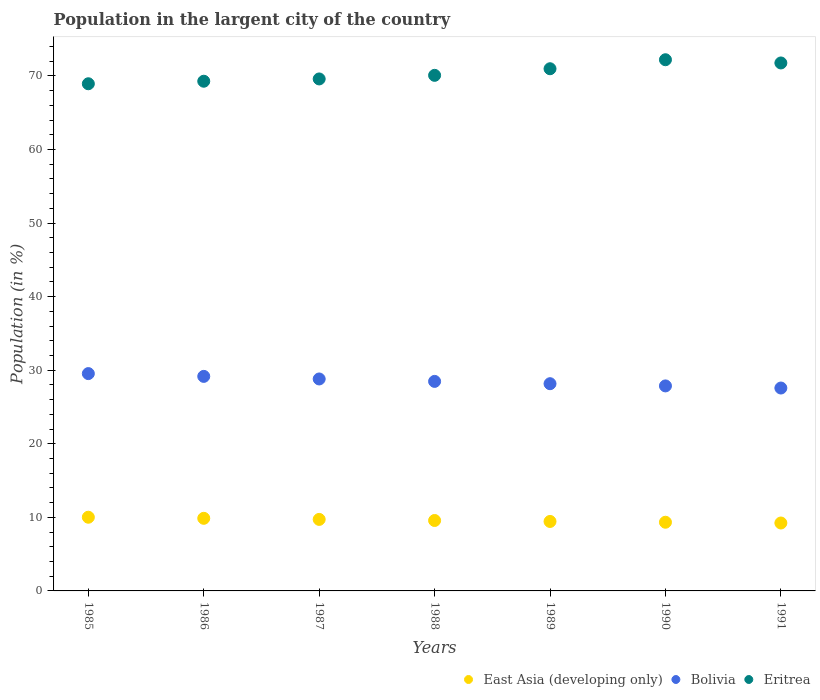How many different coloured dotlines are there?
Provide a short and direct response. 3. What is the percentage of population in the largent city in East Asia (developing only) in 1985?
Offer a terse response. 10.02. Across all years, what is the maximum percentage of population in the largent city in Bolivia?
Your answer should be very brief. 29.54. Across all years, what is the minimum percentage of population in the largent city in Eritrea?
Ensure brevity in your answer.  68.94. In which year was the percentage of population in the largent city in Eritrea maximum?
Offer a very short reply. 1990. In which year was the percentage of population in the largent city in Eritrea minimum?
Provide a short and direct response. 1985. What is the total percentage of population in the largent city in Eritrea in the graph?
Provide a succinct answer. 492.83. What is the difference between the percentage of population in the largent city in Bolivia in 1988 and that in 1991?
Provide a short and direct response. 0.9. What is the difference between the percentage of population in the largent city in Eritrea in 1990 and the percentage of population in the largent city in East Asia (developing only) in 1987?
Make the answer very short. 62.48. What is the average percentage of population in the largent city in Eritrea per year?
Offer a very short reply. 70.4. In the year 1986, what is the difference between the percentage of population in the largent city in East Asia (developing only) and percentage of population in the largent city in Bolivia?
Give a very brief answer. -19.29. In how many years, is the percentage of population in the largent city in East Asia (developing only) greater than 56 %?
Your response must be concise. 0. What is the ratio of the percentage of population in the largent city in East Asia (developing only) in 1989 to that in 1990?
Ensure brevity in your answer.  1.01. Is the percentage of population in the largent city in Eritrea in 1986 less than that in 1989?
Keep it short and to the point. Yes. What is the difference between the highest and the second highest percentage of population in the largent city in Eritrea?
Provide a succinct answer. 0.44. What is the difference between the highest and the lowest percentage of population in the largent city in Bolivia?
Your answer should be compact. 1.96. Is the sum of the percentage of population in the largent city in East Asia (developing only) in 1987 and 1990 greater than the maximum percentage of population in the largent city in Eritrea across all years?
Make the answer very short. No. Is it the case that in every year, the sum of the percentage of population in the largent city in Bolivia and percentage of population in the largent city in Eritrea  is greater than the percentage of population in the largent city in East Asia (developing only)?
Your answer should be very brief. Yes. Does the percentage of population in the largent city in East Asia (developing only) monotonically increase over the years?
Your response must be concise. No. Is the percentage of population in the largent city in Eritrea strictly greater than the percentage of population in the largent city in East Asia (developing only) over the years?
Your answer should be compact. Yes. How many dotlines are there?
Provide a short and direct response. 3. How many years are there in the graph?
Provide a succinct answer. 7. Are the values on the major ticks of Y-axis written in scientific E-notation?
Provide a short and direct response. No. Does the graph contain any zero values?
Your answer should be very brief. No. How are the legend labels stacked?
Keep it short and to the point. Horizontal. What is the title of the graph?
Give a very brief answer. Population in the largent city of the country. Does "Puerto Rico" appear as one of the legend labels in the graph?
Offer a very short reply. No. What is the label or title of the Y-axis?
Your response must be concise. Population (in %). What is the Population (in %) in East Asia (developing only) in 1985?
Provide a short and direct response. 10.02. What is the Population (in %) in Bolivia in 1985?
Your response must be concise. 29.54. What is the Population (in %) of Eritrea in 1985?
Your answer should be very brief. 68.94. What is the Population (in %) in East Asia (developing only) in 1986?
Your answer should be very brief. 9.87. What is the Population (in %) of Bolivia in 1986?
Keep it short and to the point. 29.16. What is the Population (in %) in Eritrea in 1986?
Your response must be concise. 69.28. What is the Population (in %) in East Asia (developing only) in 1987?
Provide a short and direct response. 9.72. What is the Population (in %) of Bolivia in 1987?
Your answer should be very brief. 28.81. What is the Population (in %) in Eritrea in 1987?
Keep it short and to the point. 69.59. What is the Population (in %) of East Asia (developing only) in 1988?
Keep it short and to the point. 9.57. What is the Population (in %) of Bolivia in 1988?
Provide a succinct answer. 28.48. What is the Population (in %) of Eritrea in 1988?
Provide a short and direct response. 70.08. What is the Population (in %) of East Asia (developing only) in 1989?
Ensure brevity in your answer.  9.44. What is the Population (in %) in Bolivia in 1989?
Offer a very short reply. 28.17. What is the Population (in %) in Eritrea in 1989?
Ensure brevity in your answer.  70.98. What is the Population (in %) of East Asia (developing only) in 1990?
Provide a succinct answer. 9.34. What is the Population (in %) of Bolivia in 1990?
Ensure brevity in your answer.  27.87. What is the Population (in %) in Eritrea in 1990?
Keep it short and to the point. 72.2. What is the Population (in %) of East Asia (developing only) in 1991?
Provide a succinct answer. 9.23. What is the Population (in %) in Bolivia in 1991?
Your answer should be compact. 27.58. What is the Population (in %) of Eritrea in 1991?
Offer a terse response. 71.76. Across all years, what is the maximum Population (in %) in East Asia (developing only)?
Provide a short and direct response. 10.02. Across all years, what is the maximum Population (in %) in Bolivia?
Make the answer very short. 29.54. Across all years, what is the maximum Population (in %) of Eritrea?
Give a very brief answer. 72.2. Across all years, what is the minimum Population (in %) of East Asia (developing only)?
Offer a terse response. 9.23. Across all years, what is the minimum Population (in %) in Bolivia?
Provide a succinct answer. 27.58. Across all years, what is the minimum Population (in %) of Eritrea?
Offer a terse response. 68.94. What is the total Population (in %) in East Asia (developing only) in the graph?
Keep it short and to the point. 67.19. What is the total Population (in %) in Bolivia in the graph?
Your answer should be very brief. 199.6. What is the total Population (in %) of Eritrea in the graph?
Ensure brevity in your answer.  492.83. What is the difference between the Population (in %) of East Asia (developing only) in 1985 and that in 1986?
Your answer should be compact. 0.15. What is the difference between the Population (in %) in Bolivia in 1985 and that in 1986?
Give a very brief answer. 0.38. What is the difference between the Population (in %) of Eritrea in 1985 and that in 1986?
Give a very brief answer. -0.34. What is the difference between the Population (in %) in East Asia (developing only) in 1985 and that in 1987?
Provide a short and direct response. 0.3. What is the difference between the Population (in %) of Bolivia in 1985 and that in 1987?
Keep it short and to the point. 0.73. What is the difference between the Population (in %) of Eritrea in 1985 and that in 1987?
Give a very brief answer. -0.66. What is the difference between the Population (in %) of East Asia (developing only) in 1985 and that in 1988?
Give a very brief answer. 0.44. What is the difference between the Population (in %) of Bolivia in 1985 and that in 1988?
Provide a succinct answer. 1.06. What is the difference between the Population (in %) of Eritrea in 1985 and that in 1988?
Provide a short and direct response. -1.14. What is the difference between the Population (in %) in East Asia (developing only) in 1985 and that in 1989?
Keep it short and to the point. 0.58. What is the difference between the Population (in %) of Bolivia in 1985 and that in 1989?
Provide a succinct answer. 1.37. What is the difference between the Population (in %) of Eritrea in 1985 and that in 1989?
Keep it short and to the point. -2.04. What is the difference between the Population (in %) in East Asia (developing only) in 1985 and that in 1990?
Keep it short and to the point. 0.68. What is the difference between the Population (in %) of Bolivia in 1985 and that in 1990?
Provide a succinct answer. 1.67. What is the difference between the Population (in %) in Eritrea in 1985 and that in 1990?
Your response must be concise. -3.27. What is the difference between the Population (in %) in East Asia (developing only) in 1985 and that in 1991?
Make the answer very short. 0.79. What is the difference between the Population (in %) in Bolivia in 1985 and that in 1991?
Provide a short and direct response. 1.96. What is the difference between the Population (in %) in Eritrea in 1985 and that in 1991?
Give a very brief answer. -2.83. What is the difference between the Population (in %) in East Asia (developing only) in 1986 and that in 1987?
Provide a short and direct response. 0.15. What is the difference between the Population (in %) of Bolivia in 1986 and that in 1987?
Provide a succinct answer. 0.35. What is the difference between the Population (in %) of Eritrea in 1986 and that in 1987?
Your answer should be compact. -0.31. What is the difference between the Population (in %) of East Asia (developing only) in 1986 and that in 1988?
Provide a short and direct response. 0.3. What is the difference between the Population (in %) in Bolivia in 1986 and that in 1988?
Offer a very short reply. 0.68. What is the difference between the Population (in %) in Eritrea in 1986 and that in 1988?
Give a very brief answer. -0.8. What is the difference between the Population (in %) of East Asia (developing only) in 1986 and that in 1989?
Your response must be concise. 0.43. What is the difference between the Population (in %) in Eritrea in 1986 and that in 1989?
Keep it short and to the point. -1.7. What is the difference between the Population (in %) in East Asia (developing only) in 1986 and that in 1990?
Provide a succinct answer. 0.53. What is the difference between the Population (in %) in Bolivia in 1986 and that in 1990?
Your response must be concise. 1.3. What is the difference between the Population (in %) in Eritrea in 1986 and that in 1990?
Your response must be concise. -2.92. What is the difference between the Population (in %) of East Asia (developing only) in 1986 and that in 1991?
Your response must be concise. 0.64. What is the difference between the Population (in %) of Bolivia in 1986 and that in 1991?
Provide a succinct answer. 1.58. What is the difference between the Population (in %) of Eritrea in 1986 and that in 1991?
Provide a succinct answer. -2.48. What is the difference between the Population (in %) in East Asia (developing only) in 1987 and that in 1988?
Provide a short and direct response. 0.15. What is the difference between the Population (in %) of Bolivia in 1987 and that in 1988?
Make the answer very short. 0.33. What is the difference between the Population (in %) in Eritrea in 1987 and that in 1988?
Give a very brief answer. -0.49. What is the difference between the Population (in %) in East Asia (developing only) in 1987 and that in 1989?
Make the answer very short. 0.28. What is the difference between the Population (in %) of Bolivia in 1987 and that in 1989?
Provide a succinct answer. 0.64. What is the difference between the Population (in %) in Eritrea in 1987 and that in 1989?
Your answer should be very brief. -1.39. What is the difference between the Population (in %) in East Asia (developing only) in 1987 and that in 1990?
Provide a short and direct response. 0.39. What is the difference between the Population (in %) of Bolivia in 1987 and that in 1990?
Ensure brevity in your answer.  0.94. What is the difference between the Population (in %) in Eritrea in 1987 and that in 1990?
Provide a short and direct response. -2.61. What is the difference between the Population (in %) of East Asia (developing only) in 1987 and that in 1991?
Keep it short and to the point. 0.49. What is the difference between the Population (in %) of Bolivia in 1987 and that in 1991?
Your answer should be compact. 1.23. What is the difference between the Population (in %) in Eritrea in 1987 and that in 1991?
Your answer should be compact. -2.17. What is the difference between the Population (in %) in East Asia (developing only) in 1988 and that in 1989?
Your answer should be very brief. 0.13. What is the difference between the Population (in %) of Bolivia in 1988 and that in 1989?
Provide a short and direct response. 0.31. What is the difference between the Population (in %) of Eritrea in 1988 and that in 1989?
Ensure brevity in your answer.  -0.9. What is the difference between the Population (in %) in East Asia (developing only) in 1988 and that in 1990?
Your response must be concise. 0.24. What is the difference between the Population (in %) of Bolivia in 1988 and that in 1990?
Your answer should be compact. 0.61. What is the difference between the Population (in %) of Eritrea in 1988 and that in 1990?
Your response must be concise. -2.12. What is the difference between the Population (in %) of East Asia (developing only) in 1988 and that in 1991?
Ensure brevity in your answer.  0.34. What is the difference between the Population (in %) in Bolivia in 1988 and that in 1991?
Your response must be concise. 0.9. What is the difference between the Population (in %) of Eritrea in 1988 and that in 1991?
Offer a terse response. -1.68. What is the difference between the Population (in %) of East Asia (developing only) in 1989 and that in 1990?
Provide a succinct answer. 0.11. What is the difference between the Population (in %) of Bolivia in 1989 and that in 1990?
Your answer should be compact. 0.3. What is the difference between the Population (in %) of Eritrea in 1989 and that in 1990?
Offer a terse response. -1.22. What is the difference between the Population (in %) in East Asia (developing only) in 1989 and that in 1991?
Offer a very short reply. 0.21. What is the difference between the Population (in %) of Bolivia in 1989 and that in 1991?
Ensure brevity in your answer.  0.59. What is the difference between the Population (in %) in Eritrea in 1989 and that in 1991?
Your answer should be compact. -0.79. What is the difference between the Population (in %) in East Asia (developing only) in 1990 and that in 1991?
Your response must be concise. 0.1. What is the difference between the Population (in %) in Bolivia in 1990 and that in 1991?
Your answer should be compact. 0.29. What is the difference between the Population (in %) in Eritrea in 1990 and that in 1991?
Offer a very short reply. 0.44. What is the difference between the Population (in %) in East Asia (developing only) in 1985 and the Population (in %) in Bolivia in 1986?
Offer a very short reply. -19.15. What is the difference between the Population (in %) in East Asia (developing only) in 1985 and the Population (in %) in Eritrea in 1986?
Provide a short and direct response. -59.26. What is the difference between the Population (in %) in Bolivia in 1985 and the Population (in %) in Eritrea in 1986?
Your answer should be very brief. -39.74. What is the difference between the Population (in %) of East Asia (developing only) in 1985 and the Population (in %) of Bolivia in 1987?
Make the answer very short. -18.79. What is the difference between the Population (in %) in East Asia (developing only) in 1985 and the Population (in %) in Eritrea in 1987?
Your answer should be very brief. -59.58. What is the difference between the Population (in %) of Bolivia in 1985 and the Population (in %) of Eritrea in 1987?
Provide a succinct answer. -40.05. What is the difference between the Population (in %) in East Asia (developing only) in 1985 and the Population (in %) in Bolivia in 1988?
Ensure brevity in your answer.  -18.46. What is the difference between the Population (in %) in East Asia (developing only) in 1985 and the Population (in %) in Eritrea in 1988?
Offer a very short reply. -60.06. What is the difference between the Population (in %) in Bolivia in 1985 and the Population (in %) in Eritrea in 1988?
Your answer should be compact. -40.54. What is the difference between the Population (in %) of East Asia (developing only) in 1985 and the Population (in %) of Bolivia in 1989?
Provide a short and direct response. -18.15. What is the difference between the Population (in %) in East Asia (developing only) in 1985 and the Population (in %) in Eritrea in 1989?
Ensure brevity in your answer.  -60.96. What is the difference between the Population (in %) in Bolivia in 1985 and the Population (in %) in Eritrea in 1989?
Make the answer very short. -41.44. What is the difference between the Population (in %) in East Asia (developing only) in 1985 and the Population (in %) in Bolivia in 1990?
Give a very brief answer. -17.85. What is the difference between the Population (in %) in East Asia (developing only) in 1985 and the Population (in %) in Eritrea in 1990?
Offer a terse response. -62.18. What is the difference between the Population (in %) in Bolivia in 1985 and the Population (in %) in Eritrea in 1990?
Make the answer very short. -42.66. What is the difference between the Population (in %) in East Asia (developing only) in 1985 and the Population (in %) in Bolivia in 1991?
Your answer should be compact. -17.56. What is the difference between the Population (in %) of East Asia (developing only) in 1985 and the Population (in %) of Eritrea in 1991?
Provide a succinct answer. -61.75. What is the difference between the Population (in %) in Bolivia in 1985 and the Population (in %) in Eritrea in 1991?
Your answer should be compact. -42.22. What is the difference between the Population (in %) in East Asia (developing only) in 1986 and the Population (in %) in Bolivia in 1987?
Offer a terse response. -18.94. What is the difference between the Population (in %) in East Asia (developing only) in 1986 and the Population (in %) in Eritrea in 1987?
Provide a short and direct response. -59.72. What is the difference between the Population (in %) in Bolivia in 1986 and the Population (in %) in Eritrea in 1987?
Ensure brevity in your answer.  -40.43. What is the difference between the Population (in %) in East Asia (developing only) in 1986 and the Population (in %) in Bolivia in 1988?
Your response must be concise. -18.61. What is the difference between the Population (in %) in East Asia (developing only) in 1986 and the Population (in %) in Eritrea in 1988?
Your response must be concise. -60.21. What is the difference between the Population (in %) in Bolivia in 1986 and the Population (in %) in Eritrea in 1988?
Ensure brevity in your answer.  -40.92. What is the difference between the Population (in %) in East Asia (developing only) in 1986 and the Population (in %) in Bolivia in 1989?
Provide a succinct answer. -18.3. What is the difference between the Population (in %) in East Asia (developing only) in 1986 and the Population (in %) in Eritrea in 1989?
Your answer should be compact. -61.11. What is the difference between the Population (in %) in Bolivia in 1986 and the Population (in %) in Eritrea in 1989?
Your answer should be compact. -41.82. What is the difference between the Population (in %) in East Asia (developing only) in 1986 and the Population (in %) in Bolivia in 1990?
Provide a succinct answer. -18. What is the difference between the Population (in %) of East Asia (developing only) in 1986 and the Population (in %) of Eritrea in 1990?
Make the answer very short. -62.33. What is the difference between the Population (in %) in Bolivia in 1986 and the Population (in %) in Eritrea in 1990?
Offer a terse response. -43.04. What is the difference between the Population (in %) of East Asia (developing only) in 1986 and the Population (in %) of Bolivia in 1991?
Offer a terse response. -17.71. What is the difference between the Population (in %) of East Asia (developing only) in 1986 and the Population (in %) of Eritrea in 1991?
Your answer should be very brief. -61.89. What is the difference between the Population (in %) in Bolivia in 1986 and the Population (in %) in Eritrea in 1991?
Give a very brief answer. -42.6. What is the difference between the Population (in %) in East Asia (developing only) in 1987 and the Population (in %) in Bolivia in 1988?
Ensure brevity in your answer.  -18.76. What is the difference between the Population (in %) of East Asia (developing only) in 1987 and the Population (in %) of Eritrea in 1988?
Ensure brevity in your answer.  -60.36. What is the difference between the Population (in %) in Bolivia in 1987 and the Population (in %) in Eritrea in 1988?
Keep it short and to the point. -41.27. What is the difference between the Population (in %) of East Asia (developing only) in 1987 and the Population (in %) of Bolivia in 1989?
Offer a terse response. -18.45. What is the difference between the Population (in %) in East Asia (developing only) in 1987 and the Population (in %) in Eritrea in 1989?
Keep it short and to the point. -61.26. What is the difference between the Population (in %) in Bolivia in 1987 and the Population (in %) in Eritrea in 1989?
Provide a succinct answer. -42.17. What is the difference between the Population (in %) of East Asia (developing only) in 1987 and the Population (in %) of Bolivia in 1990?
Your answer should be compact. -18.15. What is the difference between the Population (in %) of East Asia (developing only) in 1987 and the Population (in %) of Eritrea in 1990?
Your response must be concise. -62.48. What is the difference between the Population (in %) of Bolivia in 1987 and the Population (in %) of Eritrea in 1990?
Your answer should be compact. -43.39. What is the difference between the Population (in %) of East Asia (developing only) in 1987 and the Population (in %) of Bolivia in 1991?
Offer a terse response. -17.86. What is the difference between the Population (in %) in East Asia (developing only) in 1987 and the Population (in %) in Eritrea in 1991?
Your answer should be compact. -62.04. What is the difference between the Population (in %) of Bolivia in 1987 and the Population (in %) of Eritrea in 1991?
Your response must be concise. -42.95. What is the difference between the Population (in %) of East Asia (developing only) in 1988 and the Population (in %) of Bolivia in 1989?
Your answer should be compact. -18.59. What is the difference between the Population (in %) of East Asia (developing only) in 1988 and the Population (in %) of Eritrea in 1989?
Your answer should be compact. -61.4. What is the difference between the Population (in %) in Bolivia in 1988 and the Population (in %) in Eritrea in 1989?
Provide a succinct answer. -42.5. What is the difference between the Population (in %) of East Asia (developing only) in 1988 and the Population (in %) of Bolivia in 1990?
Ensure brevity in your answer.  -18.29. What is the difference between the Population (in %) of East Asia (developing only) in 1988 and the Population (in %) of Eritrea in 1990?
Keep it short and to the point. -62.63. What is the difference between the Population (in %) in Bolivia in 1988 and the Population (in %) in Eritrea in 1990?
Provide a short and direct response. -43.72. What is the difference between the Population (in %) in East Asia (developing only) in 1988 and the Population (in %) in Bolivia in 1991?
Keep it short and to the point. -18.01. What is the difference between the Population (in %) of East Asia (developing only) in 1988 and the Population (in %) of Eritrea in 1991?
Offer a very short reply. -62.19. What is the difference between the Population (in %) in Bolivia in 1988 and the Population (in %) in Eritrea in 1991?
Offer a very short reply. -43.28. What is the difference between the Population (in %) in East Asia (developing only) in 1989 and the Population (in %) in Bolivia in 1990?
Offer a terse response. -18.43. What is the difference between the Population (in %) of East Asia (developing only) in 1989 and the Population (in %) of Eritrea in 1990?
Provide a succinct answer. -62.76. What is the difference between the Population (in %) of Bolivia in 1989 and the Population (in %) of Eritrea in 1990?
Your answer should be very brief. -44.03. What is the difference between the Population (in %) in East Asia (developing only) in 1989 and the Population (in %) in Bolivia in 1991?
Make the answer very short. -18.14. What is the difference between the Population (in %) of East Asia (developing only) in 1989 and the Population (in %) of Eritrea in 1991?
Offer a terse response. -62.32. What is the difference between the Population (in %) in Bolivia in 1989 and the Population (in %) in Eritrea in 1991?
Provide a succinct answer. -43.6. What is the difference between the Population (in %) in East Asia (developing only) in 1990 and the Population (in %) in Bolivia in 1991?
Your answer should be compact. -18.24. What is the difference between the Population (in %) of East Asia (developing only) in 1990 and the Population (in %) of Eritrea in 1991?
Your answer should be very brief. -62.43. What is the difference between the Population (in %) of Bolivia in 1990 and the Population (in %) of Eritrea in 1991?
Keep it short and to the point. -43.9. What is the average Population (in %) in East Asia (developing only) per year?
Ensure brevity in your answer.  9.6. What is the average Population (in %) of Bolivia per year?
Give a very brief answer. 28.51. What is the average Population (in %) in Eritrea per year?
Your answer should be compact. 70.4. In the year 1985, what is the difference between the Population (in %) in East Asia (developing only) and Population (in %) in Bolivia?
Make the answer very short. -19.52. In the year 1985, what is the difference between the Population (in %) in East Asia (developing only) and Population (in %) in Eritrea?
Provide a succinct answer. -58.92. In the year 1985, what is the difference between the Population (in %) of Bolivia and Population (in %) of Eritrea?
Offer a terse response. -39.4. In the year 1986, what is the difference between the Population (in %) in East Asia (developing only) and Population (in %) in Bolivia?
Your answer should be very brief. -19.29. In the year 1986, what is the difference between the Population (in %) in East Asia (developing only) and Population (in %) in Eritrea?
Offer a terse response. -59.41. In the year 1986, what is the difference between the Population (in %) of Bolivia and Population (in %) of Eritrea?
Give a very brief answer. -40.12. In the year 1987, what is the difference between the Population (in %) of East Asia (developing only) and Population (in %) of Bolivia?
Give a very brief answer. -19.09. In the year 1987, what is the difference between the Population (in %) of East Asia (developing only) and Population (in %) of Eritrea?
Make the answer very short. -59.87. In the year 1987, what is the difference between the Population (in %) in Bolivia and Population (in %) in Eritrea?
Provide a succinct answer. -40.78. In the year 1988, what is the difference between the Population (in %) of East Asia (developing only) and Population (in %) of Bolivia?
Offer a terse response. -18.91. In the year 1988, what is the difference between the Population (in %) in East Asia (developing only) and Population (in %) in Eritrea?
Give a very brief answer. -60.51. In the year 1988, what is the difference between the Population (in %) of Bolivia and Population (in %) of Eritrea?
Ensure brevity in your answer.  -41.6. In the year 1989, what is the difference between the Population (in %) in East Asia (developing only) and Population (in %) in Bolivia?
Keep it short and to the point. -18.73. In the year 1989, what is the difference between the Population (in %) of East Asia (developing only) and Population (in %) of Eritrea?
Your answer should be very brief. -61.54. In the year 1989, what is the difference between the Population (in %) of Bolivia and Population (in %) of Eritrea?
Your answer should be compact. -42.81. In the year 1990, what is the difference between the Population (in %) of East Asia (developing only) and Population (in %) of Bolivia?
Provide a short and direct response. -18.53. In the year 1990, what is the difference between the Population (in %) in East Asia (developing only) and Population (in %) in Eritrea?
Offer a terse response. -62.87. In the year 1990, what is the difference between the Population (in %) of Bolivia and Population (in %) of Eritrea?
Provide a short and direct response. -44.33. In the year 1991, what is the difference between the Population (in %) of East Asia (developing only) and Population (in %) of Bolivia?
Offer a very short reply. -18.35. In the year 1991, what is the difference between the Population (in %) of East Asia (developing only) and Population (in %) of Eritrea?
Provide a short and direct response. -62.53. In the year 1991, what is the difference between the Population (in %) of Bolivia and Population (in %) of Eritrea?
Make the answer very short. -44.18. What is the ratio of the Population (in %) in East Asia (developing only) in 1985 to that in 1986?
Your response must be concise. 1.01. What is the ratio of the Population (in %) in Bolivia in 1985 to that in 1986?
Offer a very short reply. 1.01. What is the ratio of the Population (in %) of Eritrea in 1985 to that in 1986?
Your response must be concise. 0.99. What is the ratio of the Population (in %) in East Asia (developing only) in 1985 to that in 1987?
Provide a succinct answer. 1.03. What is the ratio of the Population (in %) in Bolivia in 1985 to that in 1987?
Provide a succinct answer. 1.03. What is the ratio of the Population (in %) in Eritrea in 1985 to that in 1987?
Make the answer very short. 0.99. What is the ratio of the Population (in %) in East Asia (developing only) in 1985 to that in 1988?
Your response must be concise. 1.05. What is the ratio of the Population (in %) in Bolivia in 1985 to that in 1988?
Provide a short and direct response. 1.04. What is the ratio of the Population (in %) in Eritrea in 1985 to that in 1988?
Provide a short and direct response. 0.98. What is the ratio of the Population (in %) of East Asia (developing only) in 1985 to that in 1989?
Offer a very short reply. 1.06. What is the ratio of the Population (in %) in Bolivia in 1985 to that in 1989?
Offer a very short reply. 1.05. What is the ratio of the Population (in %) in Eritrea in 1985 to that in 1989?
Provide a short and direct response. 0.97. What is the ratio of the Population (in %) in East Asia (developing only) in 1985 to that in 1990?
Your response must be concise. 1.07. What is the ratio of the Population (in %) of Bolivia in 1985 to that in 1990?
Your answer should be compact. 1.06. What is the ratio of the Population (in %) in Eritrea in 1985 to that in 1990?
Your answer should be compact. 0.95. What is the ratio of the Population (in %) of East Asia (developing only) in 1985 to that in 1991?
Your answer should be very brief. 1.09. What is the ratio of the Population (in %) in Bolivia in 1985 to that in 1991?
Give a very brief answer. 1.07. What is the ratio of the Population (in %) in Eritrea in 1985 to that in 1991?
Make the answer very short. 0.96. What is the ratio of the Population (in %) in East Asia (developing only) in 1986 to that in 1987?
Make the answer very short. 1.02. What is the ratio of the Population (in %) in Bolivia in 1986 to that in 1987?
Offer a very short reply. 1.01. What is the ratio of the Population (in %) in Eritrea in 1986 to that in 1987?
Give a very brief answer. 1. What is the ratio of the Population (in %) of East Asia (developing only) in 1986 to that in 1988?
Your answer should be very brief. 1.03. What is the ratio of the Population (in %) of Bolivia in 1986 to that in 1988?
Provide a short and direct response. 1.02. What is the ratio of the Population (in %) in Eritrea in 1986 to that in 1988?
Your answer should be compact. 0.99. What is the ratio of the Population (in %) of East Asia (developing only) in 1986 to that in 1989?
Your answer should be compact. 1.05. What is the ratio of the Population (in %) in Bolivia in 1986 to that in 1989?
Your answer should be very brief. 1.04. What is the ratio of the Population (in %) of Eritrea in 1986 to that in 1989?
Your answer should be very brief. 0.98. What is the ratio of the Population (in %) in East Asia (developing only) in 1986 to that in 1990?
Ensure brevity in your answer.  1.06. What is the ratio of the Population (in %) of Bolivia in 1986 to that in 1990?
Provide a succinct answer. 1.05. What is the ratio of the Population (in %) in Eritrea in 1986 to that in 1990?
Ensure brevity in your answer.  0.96. What is the ratio of the Population (in %) in East Asia (developing only) in 1986 to that in 1991?
Keep it short and to the point. 1.07. What is the ratio of the Population (in %) in Bolivia in 1986 to that in 1991?
Offer a terse response. 1.06. What is the ratio of the Population (in %) of Eritrea in 1986 to that in 1991?
Keep it short and to the point. 0.97. What is the ratio of the Population (in %) of East Asia (developing only) in 1987 to that in 1988?
Your response must be concise. 1.02. What is the ratio of the Population (in %) of Bolivia in 1987 to that in 1988?
Ensure brevity in your answer.  1.01. What is the ratio of the Population (in %) of East Asia (developing only) in 1987 to that in 1989?
Your response must be concise. 1.03. What is the ratio of the Population (in %) of Bolivia in 1987 to that in 1989?
Give a very brief answer. 1.02. What is the ratio of the Population (in %) of Eritrea in 1987 to that in 1989?
Make the answer very short. 0.98. What is the ratio of the Population (in %) of East Asia (developing only) in 1987 to that in 1990?
Offer a terse response. 1.04. What is the ratio of the Population (in %) in Bolivia in 1987 to that in 1990?
Provide a short and direct response. 1.03. What is the ratio of the Population (in %) of Eritrea in 1987 to that in 1990?
Your answer should be very brief. 0.96. What is the ratio of the Population (in %) in East Asia (developing only) in 1987 to that in 1991?
Offer a terse response. 1.05. What is the ratio of the Population (in %) in Bolivia in 1987 to that in 1991?
Give a very brief answer. 1.04. What is the ratio of the Population (in %) in Eritrea in 1987 to that in 1991?
Your answer should be compact. 0.97. What is the ratio of the Population (in %) in East Asia (developing only) in 1988 to that in 1989?
Your response must be concise. 1.01. What is the ratio of the Population (in %) in Bolivia in 1988 to that in 1989?
Provide a succinct answer. 1.01. What is the ratio of the Population (in %) in Eritrea in 1988 to that in 1989?
Provide a short and direct response. 0.99. What is the ratio of the Population (in %) in East Asia (developing only) in 1988 to that in 1990?
Your response must be concise. 1.03. What is the ratio of the Population (in %) in Eritrea in 1988 to that in 1990?
Provide a short and direct response. 0.97. What is the ratio of the Population (in %) in East Asia (developing only) in 1988 to that in 1991?
Provide a succinct answer. 1.04. What is the ratio of the Population (in %) of Bolivia in 1988 to that in 1991?
Offer a terse response. 1.03. What is the ratio of the Population (in %) in Eritrea in 1988 to that in 1991?
Offer a very short reply. 0.98. What is the ratio of the Population (in %) in East Asia (developing only) in 1989 to that in 1990?
Your answer should be very brief. 1.01. What is the ratio of the Population (in %) of Bolivia in 1989 to that in 1990?
Provide a succinct answer. 1.01. What is the ratio of the Population (in %) of East Asia (developing only) in 1989 to that in 1991?
Give a very brief answer. 1.02. What is the ratio of the Population (in %) in Bolivia in 1989 to that in 1991?
Keep it short and to the point. 1.02. What is the ratio of the Population (in %) of Eritrea in 1989 to that in 1991?
Offer a very short reply. 0.99. What is the ratio of the Population (in %) in East Asia (developing only) in 1990 to that in 1991?
Offer a very short reply. 1.01. What is the ratio of the Population (in %) in Bolivia in 1990 to that in 1991?
Offer a terse response. 1.01. What is the difference between the highest and the second highest Population (in %) of East Asia (developing only)?
Ensure brevity in your answer.  0.15. What is the difference between the highest and the second highest Population (in %) of Bolivia?
Keep it short and to the point. 0.38. What is the difference between the highest and the second highest Population (in %) of Eritrea?
Give a very brief answer. 0.44. What is the difference between the highest and the lowest Population (in %) in East Asia (developing only)?
Offer a terse response. 0.79. What is the difference between the highest and the lowest Population (in %) of Bolivia?
Make the answer very short. 1.96. What is the difference between the highest and the lowest Population (in %) in Eritrea?
Offer a very short reply. 3.27. 